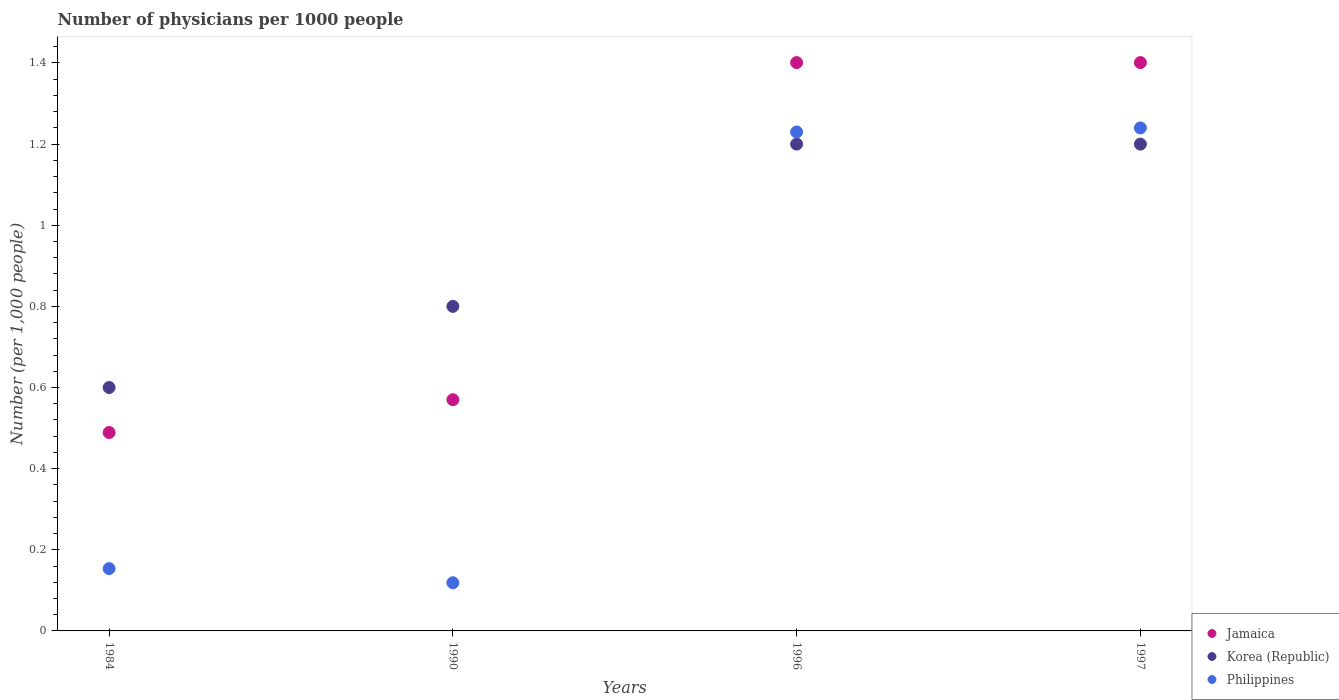Is the number of dotlines equal to the number of legend labels?
Make the answer very short. Yes. What is the number of physicians in Korea (Republic) in 1997?
Make the answer very short. 1.2. Across all years, what is the maximum number of physicians in Korea (Republic)?
Your answer should be compact. 1.2. Across all years, what is the minimum number of physicians in Jamaica?
Your response must be concise. 0.49. In which year was the number of physicians in Korea (Republic) maximum?
Your answer should be compact. 1996. What is the total number of physicians in Philippines in the graph?
Offer a terse response. 2.74. What is the difference between the number of physicians in Korea (Republic) in 1984 and that in 1990?
Offer a very short reply. -0.2. What is the difference between the number of physicians in Philippines in 1984 and the number of physicians in Korea (Republic) in 1990?
Your answer should be compact. -0.65. What is the average number of physicians in Philippines per year?
Your answer should be very brief. 0.69. In the year 1996, what is the difference between the number of physicians in Jamaica and number of physicians in Korea (Republic)?
Your answer should be very brief. 0.2. In how many years, is the number of physicians in Jamaica greater than 1.4000000000000001?
Offer a terse response. 2. What is the ratio of the number of physicians in Korea (Republic) in 1990 to that in 1997?
Offer a terse response. 0.67. What is the difference between the highest and the lowest number of physicians in Jamaica?
Make the answer very short. 0.91. Is the sum of the number of physicians in Jamaica in 1990 and 1996 greater than the maximum number of physicians in Philippines across all years?
Make the answer very short. Yes. Is the number of physicians in Korea (Republic) strictly less than the number of physicians in Jamaica over the years?
Provide a short and direct response. No. How many dotlines are there?
Offer a terse response. 3. Does the graph contain any zero values?
Your answer should be compact. No. Where does the legend appear in the graph?
Offer a terse response. Bottom right. How many legend labels are there?
Your response must be concise. 3. What is the title of the graph?
Ensure brevity in your answer.  Number of physicians per 1000 people. Does "Latvia" appear as one of the legend labels in the graph?
Ensure brevity in your answer.  No. What is the label or title of the X-axis?
Your answer should be very brief. Years. What is the label or title of the Y-axis?
Your answer should be very brief. Number (per 1,0 people). What is the Number (per 1,000 people) in Jamaica in 1984?
Keep it short and to the point. 0.49. What is the Number (per 1,000 people) in Korea (Republic) in 1984?
Offer a terse response. 0.6. What is the Number (per 1,000 people) in Philippines in 1984?
Your answer should be compact. 0.15. What is the Number (per 1,000 people) of Jamaica in 1990?
Keep it short and to the point. 0.57. What is the Number (per 1,000 people) of Philippines in 1990?
Offer a terse response. 0.12. What is the Number (per 1,000 people) in Jamaica in 1996?
Your answer should be compact. 1.4. What is the Number (per 1,000 people) in Philippines in 1996?
Make the answer very short. 1.23. What is the Number (per 1,000 people) in Jamaica in 1997?
Your response must be concise. 1.4. What is the Number (per 1,000 people) of Philippines in 1997?
Your answer should be compact. 1.24. Across all years, what is the maximum Number (per 1,000 people) in Jamaica?
Ensure brevity in your answer.  1.4. Across all years, what is the maximum Number (per 1,000 people) in Korea (Republic)?
Your answer should be compact. 1.2. Across all years, what is the maximum Number (per 1,000 people) in Philippines?
Your answer should be compact. 1.24. Across all years, what is the minimum Number (per 1,000 people) in Jamaica?
Provide a succinct answer. 0.49. Across all years, what is the minimum Number (per 1,000 people) of Korea (Republic)?
Keep it short and to the point. 0.6. Across all years, what is the minimum Number (per 1,000 people) of Philippines?
Ensure brevity in your answer.  0.12. What is the total Number (per 1,000 people) of Jamaica in the graph?
Offer a very short reply. 3.86. What is the total Number (per 1,000 people) of Korea (Republic) in the graph?
Your answer should be very brief. 3.8. What is the total Number (per 1,000 people) in Philippines in the graph?
Your answer should be very brief. 2.74. What is the difference between the Number (per 1,000 people) in Jamaica in 1984 and that in 1990?
Offer a terse response. -0.08. What is the difference between the Number (per 1,000 people) of Korea (Republic) in 1984 and that in 1990?
Make the answer very short. -0.2. What is the difference between the Number (per 1,000 people) of Philippines in 1984 and that in 1990?
Keep it short and to the point. 0.03. What is the difference between the Number (per 1,000 people) of Jamaica in 1984 and that in 1996?
Offer a terse response. -0.91. What is the difference between the Number (per 1,000 people) of Philippines in 1984 and that in 1996?
Your answer should be compact. -1.08. What is the difference between the Number (per 1,000 people) of Jamaica in 1984 and that in 1997?
Keep it short and to the point. -0.91. What is the difference between the Number (per 1,000 people) in Korea (Republic) in 1984 and that in 1997?
Offer a terse response. -0.6. What is the difference between the Number (per 1,000 people) in Philippines in 1984 and that in 1997?
Your answer should be compact. -1.09. What is the difference between the Number (per 1,000 people) in Jamaica in 1990 and that in 1996?
Your answer should be compact. -0.83. What is the difference between the Number (per 1,000 people) of Philippines in 1990 and that in 1996?
Offer a very short reply. -1.11. What is the difference between the Number (per 1,000 people) of Jamaica in 1990 and that in 1997?
Give a very brief answer. -0.83. What is the difference between the Number (per 1,000 people) in Philippines in 1990 and that in 1997?
Your response must be concise. -1.12. What is the difference between the Number (per 1,000 people) of Jamaica in 1996 and that in 1997?
Provide a succinct answer. 0. What is the difference between the Number (per 1,000 people) in Philippines in 1996 and that in 1997?
Your response must be concise. -0.01. What is the difference between the Number (per 1,000 people) in Jamaica in 1984 and the Number (per 1,000 people) in Korea (Republic) in 1990?
Ensure brevity in your answer.  -0.31. What is the difference between the Number (per 1,000 people) in Jamaica in 1984 and the Number (per 1,000 people) in Philippines in 1990?
Provide a short and direct response. 0.37. What is the difference between the Number (per 1,000 people) of Korea (Republic) in 1984 and the Number (per 1,000 people) of Philippines in 1990?
Make the answer very short. 0.48. What is the difference between the Number (per 1,000 people) of Jamaica in 1984 and the Number (per 1,000 people) of Korea (Republic) in 1996?
Give a very brief answer. -0.71. What is the difference between the Number (per 1,000 people) in Jamaica in 1984 and the Number (per 1,000 people) in Philippines in 1996?
Make the answer very short. -0.74. What is the difference between the Number (per 1,000 people) of Korea (Republic) in 1984 and the Number (per 1,000 people) of Philippines in 1996?
Ensure brevity in your answer.  -0.63. What is the difference between the Number (per 1,000 people) in Jamaica in 1984 and the Number (per 1,000 people) in Korea (Republic) in 1997?
Give a very brief answer. -0.71. What is the difference between the Number (per 1,000 people) in Jamaica in 1984 and the Number (per 1,000 people) in Philippines in 1997?
Provide a short and direct response. -0.75. What is the difference between the Number (per 1,000 people) in Korea (Republic) in 1984 and the Number (per 1,000 people) in Philippines in 1997?
Provide a short and direct response. -0.64. What is the difference between the Number (per 1,000 people) in Jamaica in 1990 and the Number (per 1,000 people) in Korea (Republic) in 1996?
Offer a terse response. -0.63. What is the difference between the Number (per 1,000 people) of Jamaica in 1990 and the Number (per 1,000 people) of Philippines in 1996?
Keep it short and to the point. -0.66. What is the difference between the Number (per 1,000 people) in Korea (Republic) in 1990 and the Number (per 1,000 people) in Philippines in 1996?
Provide a short and direct response. -0.43. What is the difference between the Number (per 1,000 people) in Jamaica in 1990 and the Number (per 1,000 people) in Korea (Republic) in 1997?
Ensure brevity in your answer.  -0.63. What is the difference between the Number (per 1,000 people) of Jamaica in 1990 and the Number (per 1,000 people) of Philippines in 1997?
Give a very brief answer. -0.67. What is the difference between the Number (per 1,000 people) in Korea (Republic) in 1990 and the Number (per 1,000 people) in Philippines in 1997?
Offer a very short reply. -0.44. What is the difference between the Number (per 1,000 people) of Jamaica in 1996 and the Number (per 1,000 people) of Korea (Republic) in 1997?
Provide a short and direct response. 0.2. What is the difference between the Number (per 1,000 people) of Jamaica in 1996 and the Number (per 1,000 people) of Philippines in 1997?
Provide a succinct answer. 0.16. What is the difference between the Number (per 1,000 people) of Korea (Republic) in 1996 and the Number (per 1,000 people) of Philippines in 1997?
Your answer should be compact. -0.04. What is the average Number (per 1,000 people) of Jamaica per year?
Give a very brief answer. 0.97. What is the average Number (per 1,000 people) in Philippines per year?
Your response must be concise. 0.69. In the year 1984, what is the difference between the Number (per 1,000 people) in Jamaica and Number (per 1,000 people) in Korea (Republic)?
Provide a succinct answer. -0.11. In the year 1984, what is the difference between the Number (per 1,000 people) of Jamaica and Number (per 1,000 people) of Philippines?
Make the answer very short. 0.34. In the year 1984, what is the difference between the Number (per 1,000 people) of Korea (Republic) and Number (per 1,000 people) of Philippines?
Make the answer very short. 0.45. In the year 1990, what is the difference between the Number (per 1,000 people) in Jamaica and Number (per 1,000 people) in Korea (Republic)?
Provide a short and direct response. -0.23. In the year 1990, what is the difference between the Number (per 1,000 people) in Jamaica and Number (per 1,000 people) in Philippines?
Offer a terse response. 0.45. In the year 1990, what is the difference between the Number (per 1,000 people) in Korea (Republic) and Number (per 1,000 people) in Philippines?
Give a very brief answer. 0.68. In the year 1996, what is the difference between the Number (per 1,000 people) in Jamaica and Number (per 1,000 people) in Korea (Republic)?
Offer a terse response. 0.2. In the year 1996, what is the difference between the Number (per 1,000 people) in Jamaica and Number (per 1,000 people) in Philippines?
Offer a very short reply. 0.17. In the year 1996, what is the difference between the Number (per 1,000 people) of Korea (Republic) and Number (per 1,000 people) of Philippines?
Your answer should be very brief. -0.03. In the year 1997, what is the difference between the Number (per 1,000 people) in Jamaica and Number (per 1,000 people) in Korea (Republic)?
Provide a short and direct response. 0.2. In the year 1997, what is the difference between the Number (per 1,000 people) in Jamaica and Number (per 1,000 people) in Philippines?
Offer a very short reply. 0.16. In the year 1997, what is the difference between the Number (per 1,000 people) in Korea (Republic) and Number (per 1,000 people) in Philippines?
Offer a very short reply. -0.04. What is the ratio of the Number (per 1,000 people) of Jamaica in 1984 to that in 1990?
Your answer should be compact. 0.86. What is the ratio of the Number (per 1,000 people) in Korea (Republic) in 1984 to that in 1990?
Provide a succinct answer. 0.75. What is the ratio of the Number (per 1,000 people) of Philippines in 1984 to that in 1990?
Keep it short and to the point. 1.29. What is the ratio of the Number (per 1,000 people) of Jamaica in 1984 to that in 1996?
Your answer should be very brief. 0.35. What is the ratio of the Number (per 1,000 people) of Philippines in 1984 to that in 1996?
Offer a terse response. 0.12. What is the ratio of the Number (per 1,000 people) in Jamaica in 1984 to that in 1997?
Your answer should be very brief. 0.35. What is the ratio of the Number (per 1,000 people) of Korea (Republic) in 1984 to that in 1997?
Your answer should be very brief. 0.5. What is the ratio of the Number (per 1,000 people) in Philippines in 1984 to that in 1997?
Keep it short and to the point. 0.12. What is the ratio of the Number (per 1,000 people) in Jamaica in 1990 to that in 1996?
Offer a terse response. 0.41. What is the ratio of the Number (per 1,000 people) of Korea (Republic) in 1990 to that in 1996?
Offer a terse response. 0.67. What is the ratio of the Number (per 1,000 people) in Philippines in 1990 to that in 1996?
Your answer should be compact. 0.1. What is the ratio of the Number (per 1,000 people) in Jamaica in 1990 to that in 1997?
Offer a terse response. 0.41. What is the ratio of the Number (per 1,000 people) of Philippines in 1990 to that in 1997?
Keep it short and to the point. 0.1. What is the ratio of the Number (per 1,000 people) in Jamaica in 1996 to that in 1997?
Give a very brief answer. 1. What is the ratio of the Number (per 1,000 people) in Korea (Republic) in 1996 to that in 1997?
Offer a very short reply. 1. What is the difference between the highest and the second highest Number (per 1,000 people) of Jamaica?
Provide a succinct answer. 0. What is the difference between the highest and the second highest Number (per 1,000 people) in Philippines?
Your answer should be very brief. 0.01. What is the difference between the highest and the lowest Number (per 1,000 people) of Jamaica?
Your answer should be very brief. 0.91. What is the difference between the highest and the lowest Number (per 1,000 people) in Korea (Republic)?
Ensure brevity in your answer.  0.6. What is the difference between the highest and the lowest Number (per 1,000 people) of Philippines?
Provide a short and direct response. 1.12. 